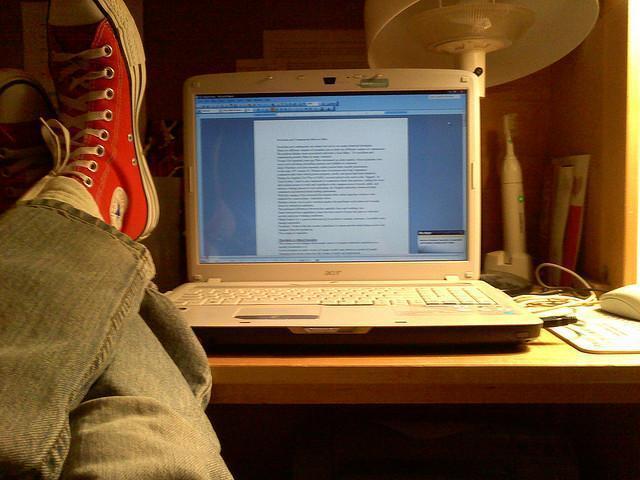How many toothbrushes are in the photo?
Give a very brief answer. 1. How many street signs with a horse in it?
Give a very brief answer. 0. 